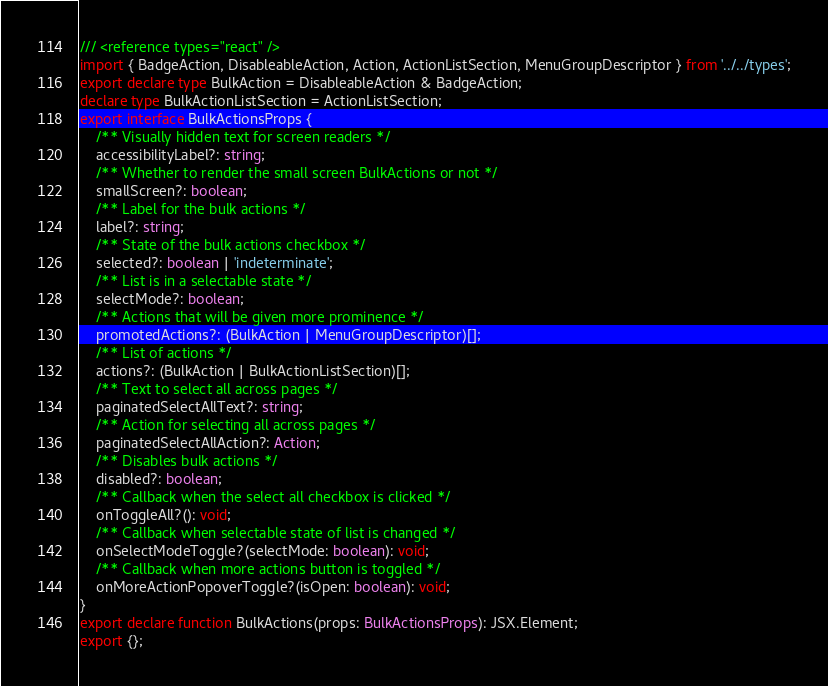<code> <loc_0><loc_0><loc_500><loc_500><_TypeScript_>/// <reference types="react" />
import { BadgeAction, DisableableAction, Action, ActionListSection, MenuGroupDescriptor } from '../../types';
export declare type BulkAction = DisableableAction & BadgeAction;
declare type BulkActionListSection = ActionListSection;
export interface BulkActionsProps {
    /** Visually hidden text for screen readers */
    accessibilityLabel?: string;
    /** Whether to render the small screen BulkActions or not */
    smallScreen?: boolean;
    /** Label for the bulk actions */
    label?: string;
    /** State of the bulk actions checkbox */
    selected?: boolean | 'indeterminate';
    /** List is in a selectable state */
    selectMode?: boolean;
    /** Actions that will be given more prominence */
    promotedActions?: (BulkAction | MenuGroupDescriptor)[];
    /** List of actions */
    actions?: (BulkAction | BulkActionListSection)[];
    /** Text to select all across pages */
    paginatedSelectAllText?: string;
    /** Action for selecting all across pages */
    paginatedSelectAllAction?: Action;
    /** Disables bulk actions */
    disabled?: boolean;
    /** Callback when the select all checkbox is clicked */
    onToggleAll?(): void;
    /** Callback when selectable state of list is changed */
    onSelectModeToggle?(selectMode: boolean): void;
    /** Callback when more actions button is toggled */
    onMoreActionPopoverToggle?(isOpen: boolean): void;
}
export declare function BulkActions(props: BulkActionsProps): JSX.Element;
export {};
</code> 